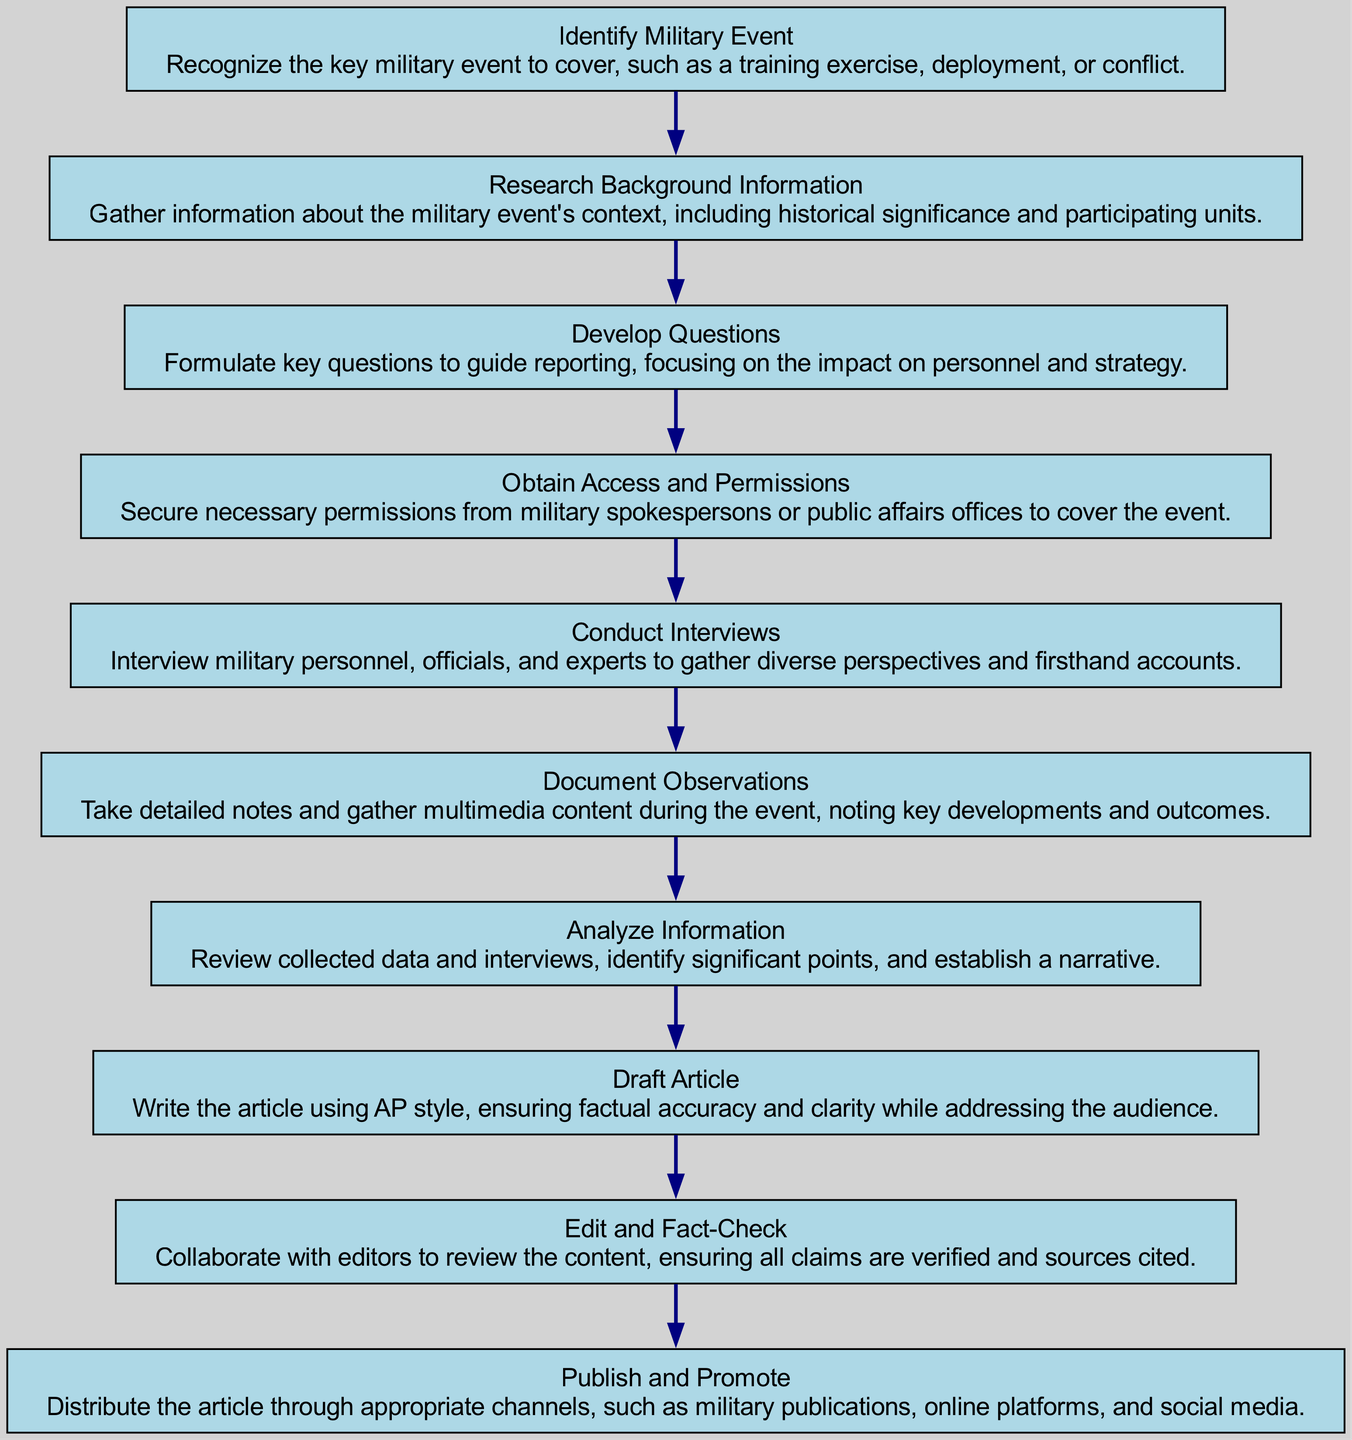What is the first step in the reporting process? The first step in the flowchart is "Identify Military Event." This step requires recognizing the key military event to cover.
Answer: Identify Military Event How many nodes are in the diagram? There are ten nodes in the diagram, each representing a different step in the reporting process.
Answer: 10 What is the last step of the reporting process? The final step in the flowchart is "Publish and Promote." This step involves distributing the article through various channels.
Answer: Publish and Promote Which step follows "Analyze Information"? The step that follows "Analyze Information" is "Draft Article." This indicates that after analyzing, the journalist proceeds to write the article.
Answer: Draft Article What step requires permissions from military spokespersons? The step "Obtain Access and Permissions" is where journalists are required to secure necessary permissions before covering the event.
Answer: Obtain Access and Permissions What is the relationship between "Conduct Interviews" and "Document Observations"? "Conduct Interviews" occurs before "Document Observations" in the flow, showing that interviews are done prior to documenting observations.
Answer: Conduct Interviews → Document Observations What is a key focus during the "Develop Questions" step? During "Develop Questions," the key focus is on formulating questions that guide reporting, particularly regarding the impact on personnel and strategy.
Answer: Impact on personnel and strategy Which two steps are directly connected and relate to article quality? The steps "Edit and Fact-Check" and "Draft Article" are directly connected, relating to the quality and accuracy of the published work.
Answer: Edit and Fact-Check → Draft Article What type of information is analyzed in the "Analyze Information" step? The information analyzed includes collected data and interviews to identify significant points and establish a narrative, forming the foundation for the article.
Answer: Collected data and interviews 